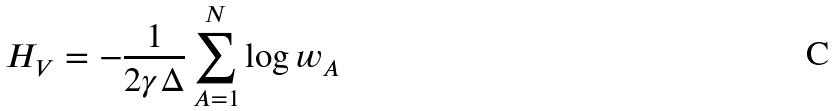Convert formula to latex. <formula><loc_0><loc_0><loc_500><loc_500>H _ { V } = - \frac { 1 } { 2 \gamma \Delta } \sum _ { A = 1 } ^ { N } \log w _ { A }</formula> 